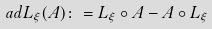Convert formula to latex. <formula><loc_0><loc_0><loc_500><loc_500>\ a d L _ { \xi } ( A ) \colon = L _ { \xi } \circ A - A \circ L _ { \xi }</formula> 